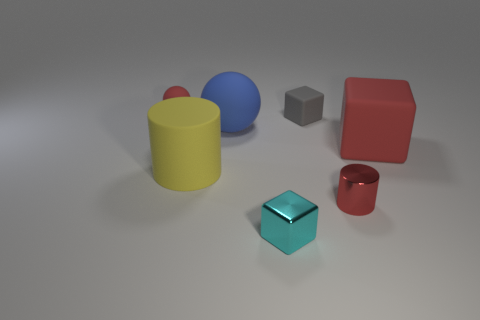Add 3 small shiny cylinders. How many objects exist? 10 Subtract all cylinders. How many objects are left? 5 Subtract all cyan metal objects. Subtract all big cylinders. How many objects are left? 5 Add 1 small cyan cubes. How many small cyan cubes are left? 2 Add 7 purple rubber objects. How many purple rubber objects exist? 7 Subtract 1 red cubes. How many objects are left? 6 